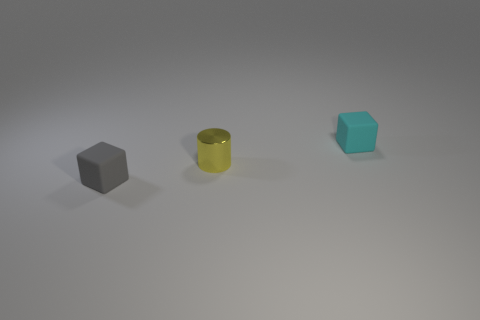Can you describe the texture of the objects shown? Certainly, the objects appear to have different textures: the small gray cube is matte, absorbing most of the light, the yellow object has a reflective metallic finish, and the small blue cube appears slightly translucent and slightly reflective. 